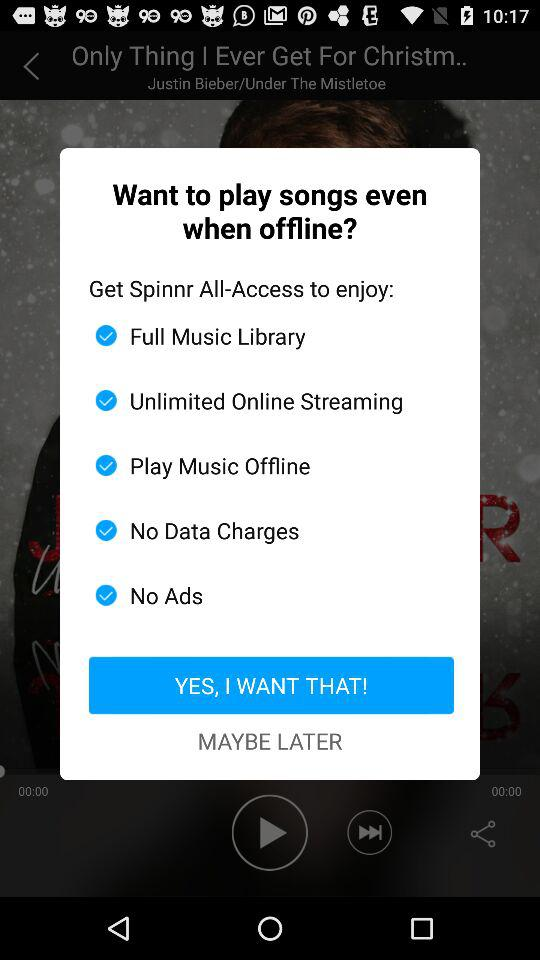What is the song name? The song name is "Only Thing I Ever Get For Christm..". 